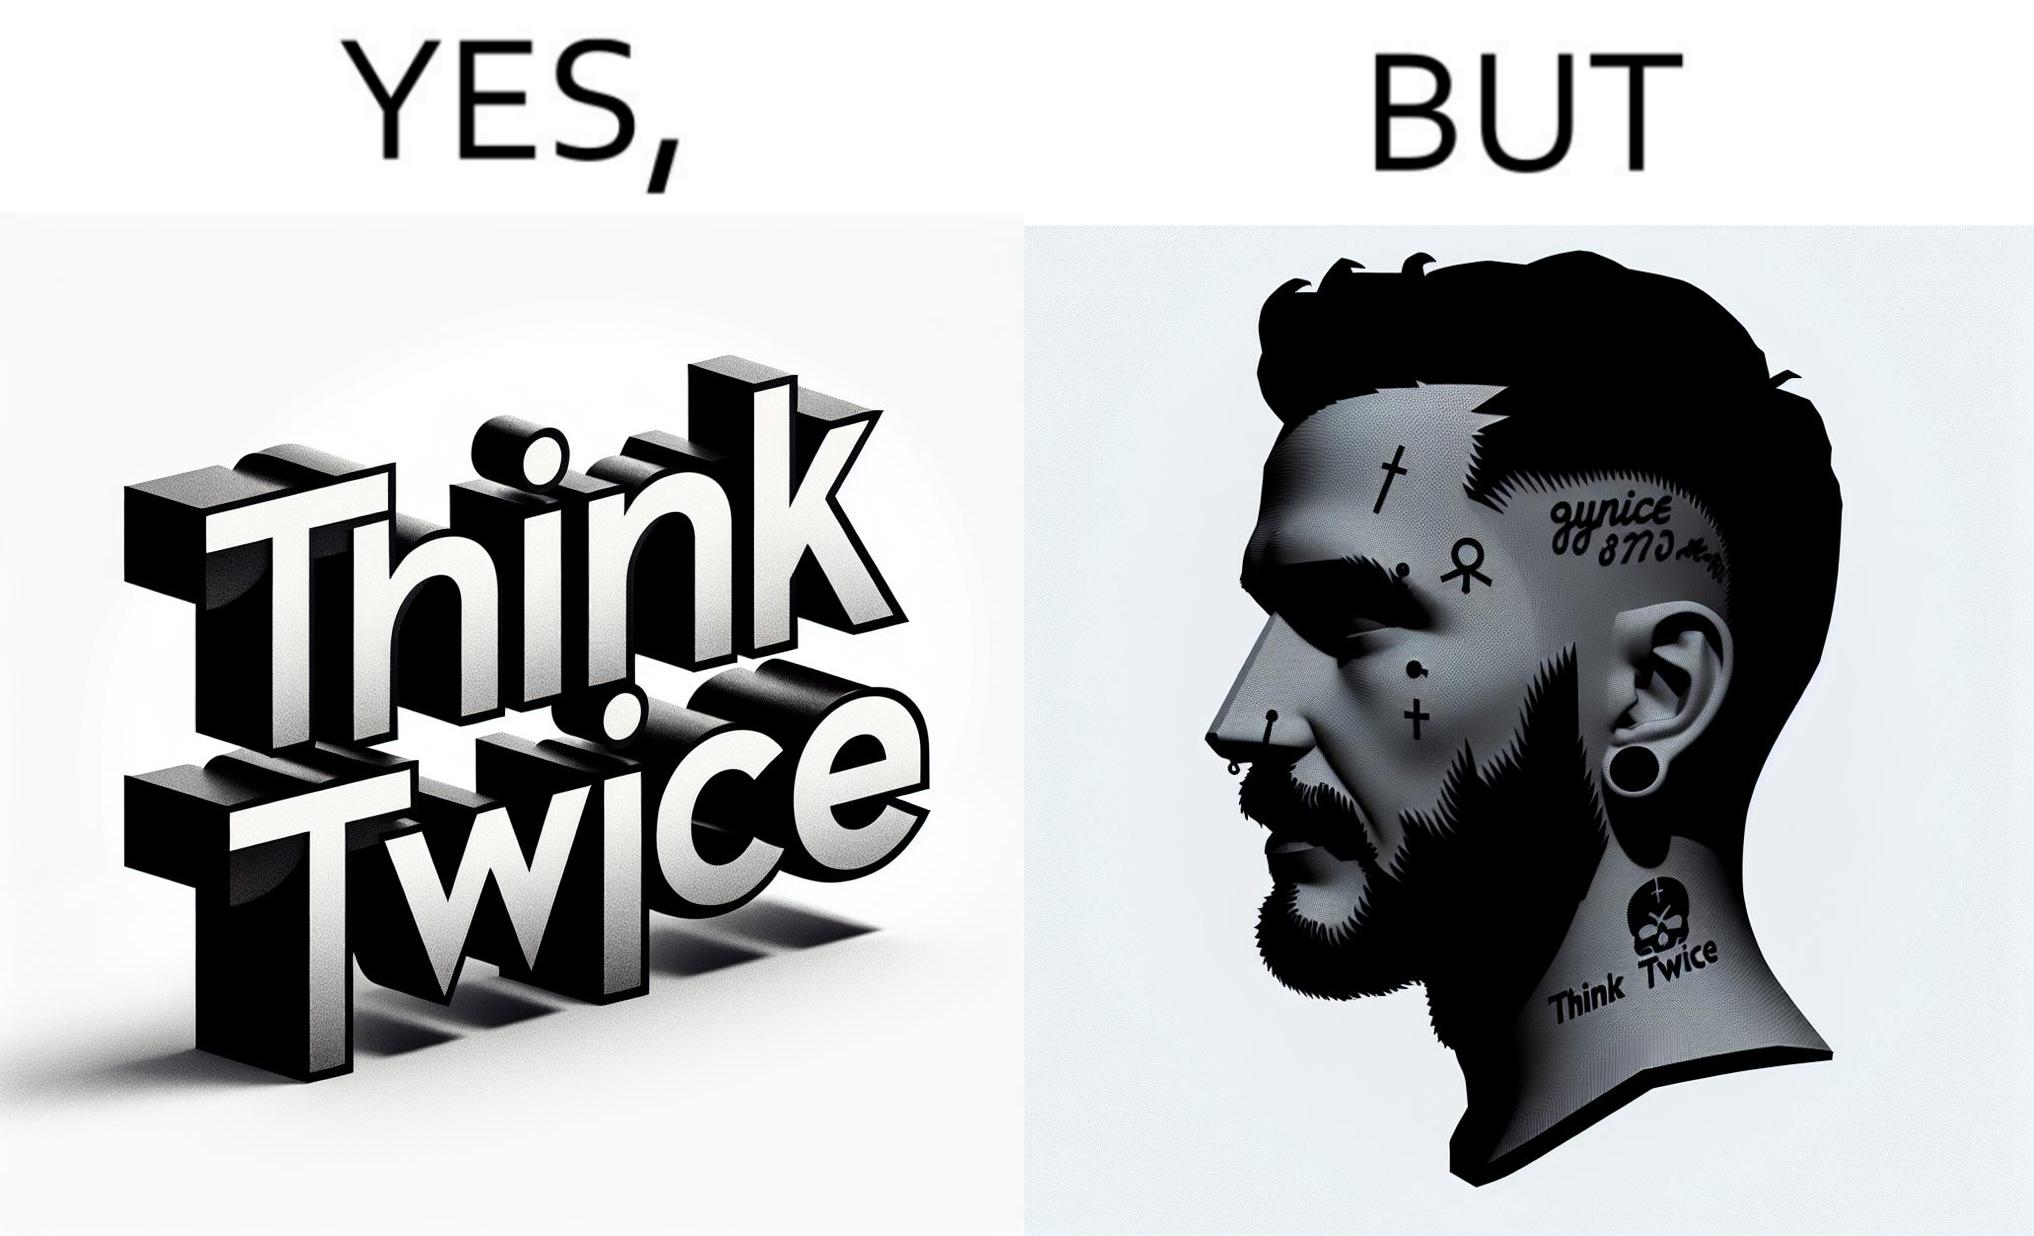Does this image contain satire or humor? Yes, this image is satirical. 